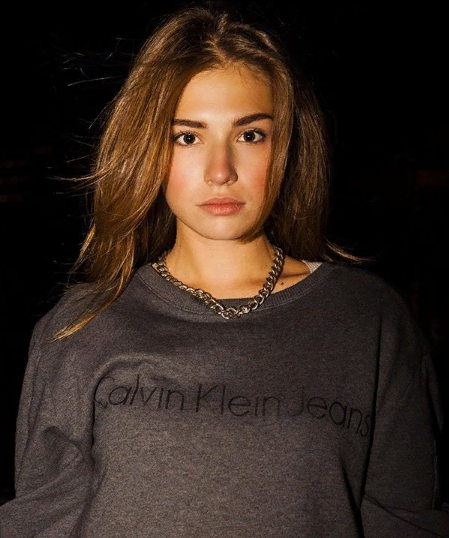Как думаешь какие 7 имён подходят для девушки на фото? Предположительно сколько ей лет? Какие 3 участника корейской группы - BTS нравятся(близки) девушке на фото? Кто ей нравится больше по внешности(красоте лице, красоте глаз) из всех 7 участников BTS? Какие глаза(разрез, форма, тип) каждого участника нравятся моей девушке на фото в процентном соотношении? Кто ей нравится по голосу(вокалу, тембру) - из каждого участников BTS в процентном соотношении? Какие 3 участника BTS наиболее похожи внешне, визуально на мою девушку на фото в процентном соотношении? Какие 3 участника BTS ближе по внешности девушке на фото по её мнению? Какие 3 участника На какие 97 народов(национальностей) похожа внешне(визуально) девушка на фото? На какие 7 типов европеоидной расы и  7 типов монголоидной расы похожа моя девушка на фото? Оцени её красоту и 100-бальной и 10-бальной шкале. Насколько красивое лицо у моей девушки на фото? Какие самые красивые у неё черты лица(глаза, губы, брови, нос, уши)? Какие 11 цветов ей нравятся больше всего и подходят ей по внешности? Какие 11 цифр от 0 до 100 ей нравятся, то есть подходят больше всего и она их любит больше всего? На какие 11 животных  внешне(визуально) похожа девушка на фото? Какие 11 животных ей больше всего нравятся визуально(внешне) и она себя с ними ассоциирует? Пожалуйста, опишите внешность девушки на фото более подробно. Например, опишите форму ее лица, цвет глаз, форму бровей, тип носа и форму губ. Также опишите ее стиль одежды и прическу. 